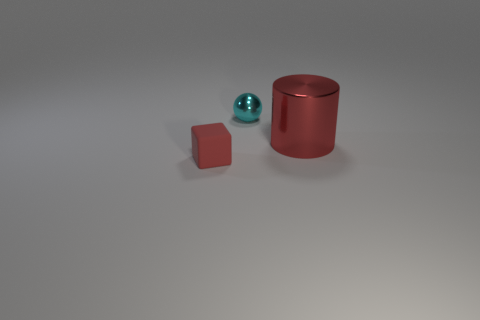Add 3 green rubber blocks. How many objects exist? 6 Subtract all balls. How many objects are left? 2 Add 1 large gray metallic things. How many large gray metallic things exist? 1 Subtract 0 red spheres. How many objects are left? 3 Subtract all cyan balls. Subtract all red metallic objects. How many objects are left? 1 Add 1 tiny red matte blocks. How many tiny red matte blocks are left? 2 